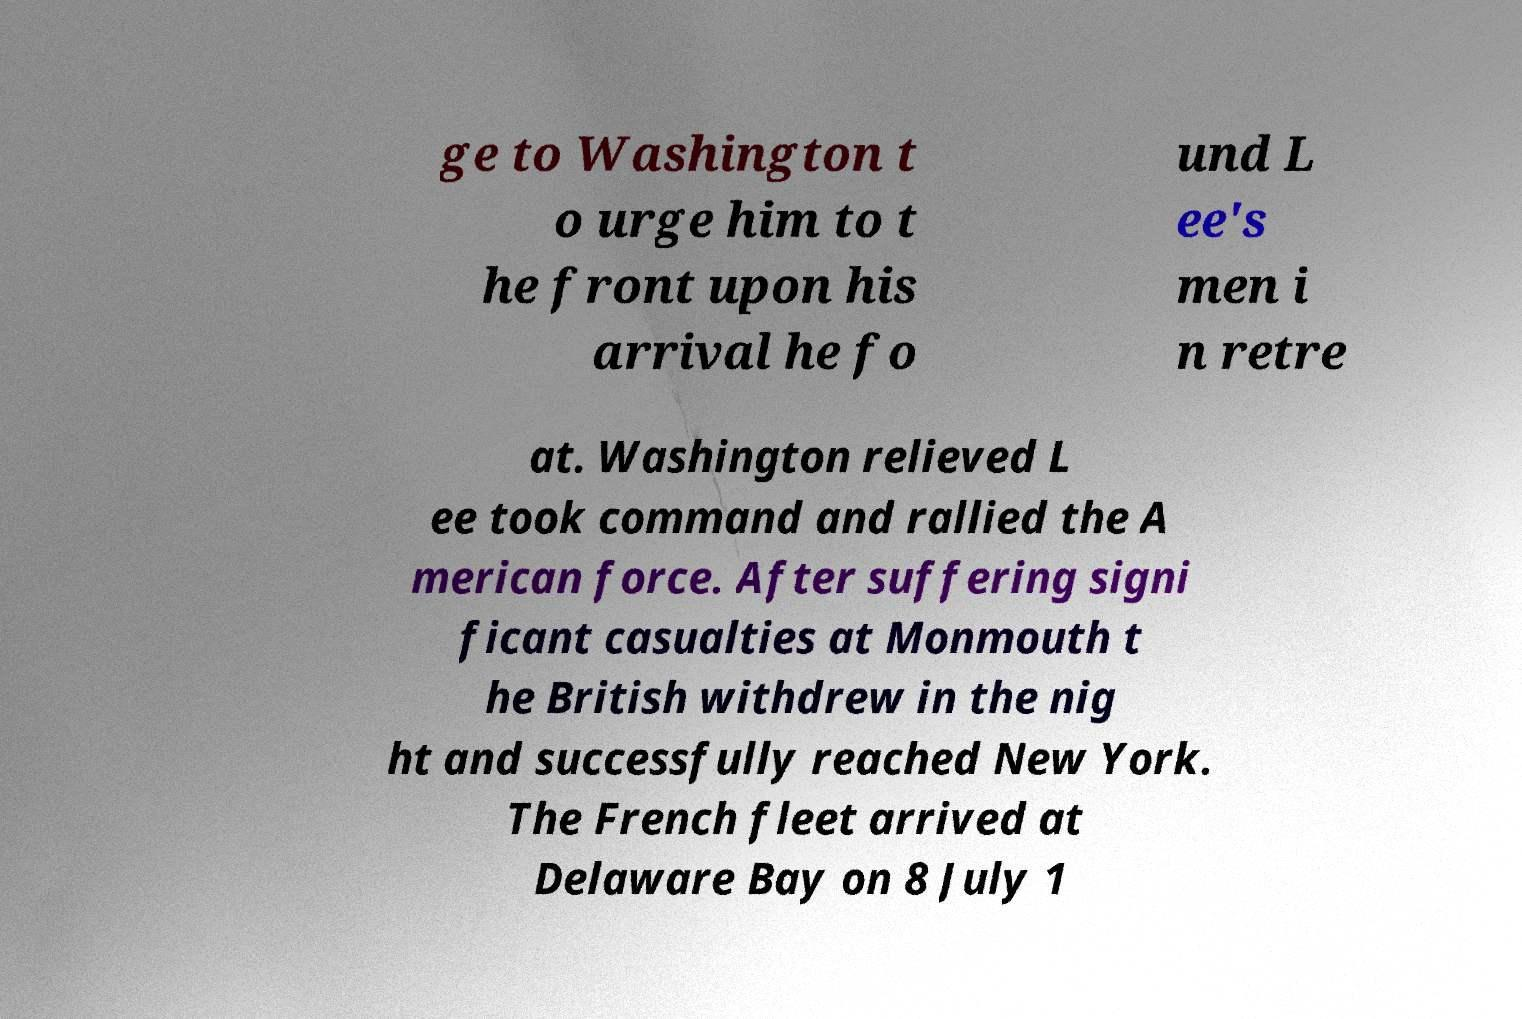Please identify and transcribe the text found in this image. ge to Washington t o urge him to t he front upon his arrival he fo und L ee's men i n retre at. Washington relieved L ee took command and rallied the A merican force. After suffering signi ficant casualties at Monmouth t he British withdrew in the nig ht and successfully reached New York. The French fleet arrived at Delaware Bay on 8 July 1 